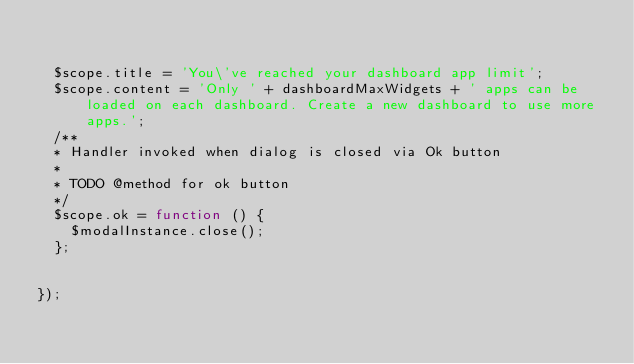<code> <loc_0><loc_0><loc_500><loc_500><_JavaScript_>

	$scope.title = 'You\'ve reached your dashboard app limit';
	$scope.content = 'Only ' + dashboardMaxWidgets + ' apps can be loaded on each dashboard. Create a new dashboard to use more apps.';
	/**
	* Handler invoked when dialog is closed via Ok button
	*
	* TODO @method for ok button
	*/
	$scope.ok = function () {
	  $modalInstance.close();
	};


});
</code> 